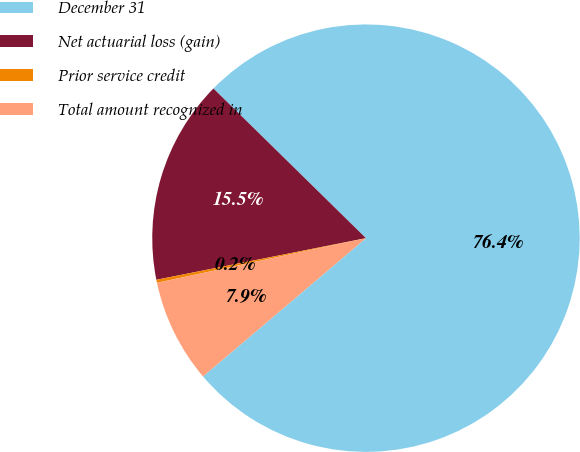Convert chart to OTSL. <chart><loc_0><loc_0><loc_500><loc_500><pie_chart><fcel>December 31<fcel>Net actuarial loss (gain)<fcel>Prior service credit<fcel>Total amount recognized in<nl><fcel>76.45%<fcel>15.47%<fcel>0.23%<fcel>7.85%<nl></chart> 